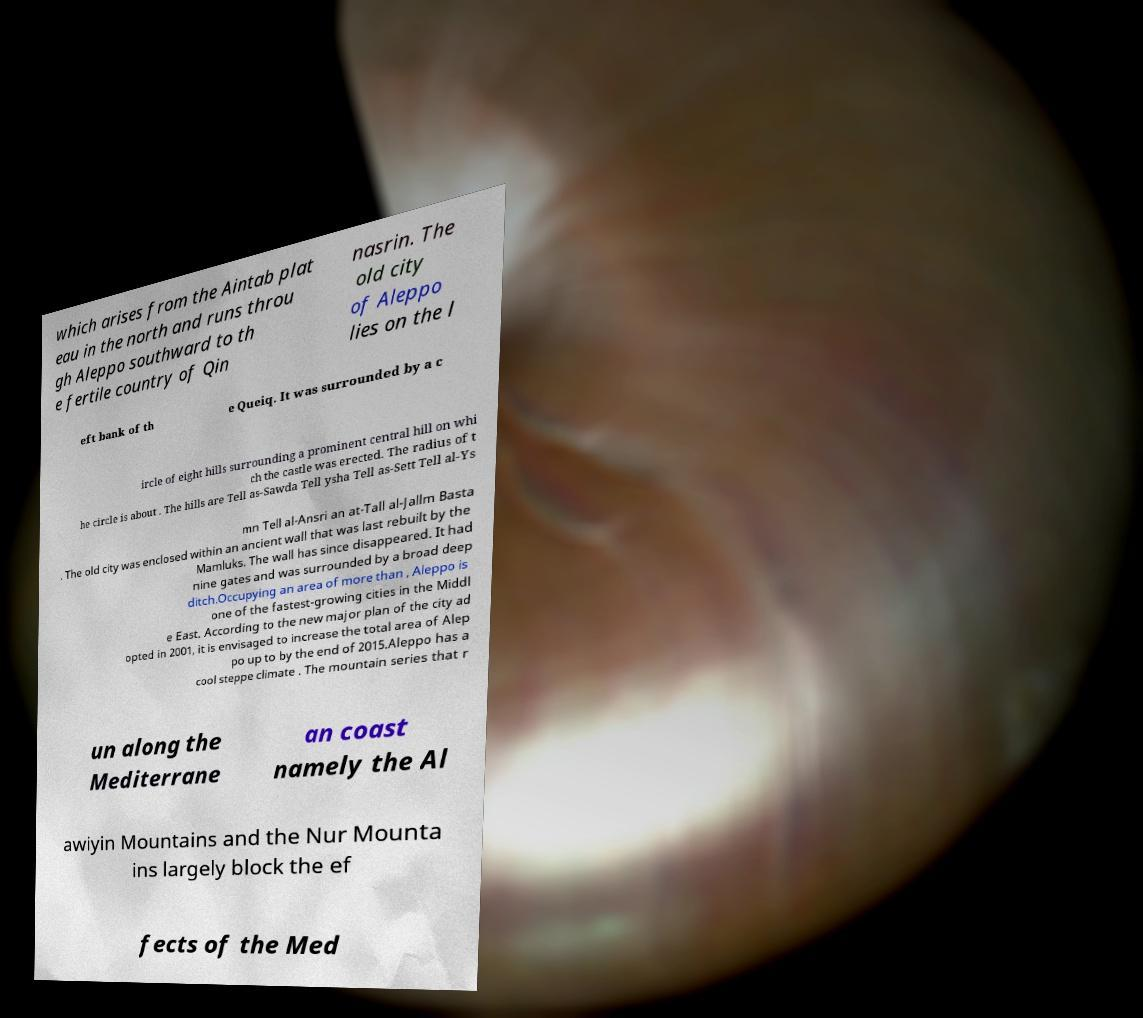Can you read and provide the text displayed in the image?This photo seems to have some interesting text. Can you extract and type it out for me? which arises from the Aintab plat eau in the north and runs throu gh Aleppo southward to th e fertile country of Qin nasrin. The old city of Aleppo lies on the l eft bank of th e Queiq. It was surrounded by a c ircle of eight hills surrounding a prominent central hill on whi ch the castle was erected. The radius of t he circle is about . The hills are Tell as-Sawda Tell ysha Tell as-Sett Tell al-Ys mn Tell al-Ansri an at-Tall al-Jallm Basta . The old city was enclosed within an ancient wall that was last rebuilt by the Mamluks. The wall has since disappeared. It had nine gates and was surrounded by a broad deep ditch.Occupying an area of more than , Aleppo is one of the fastest-growing cities in the Middl e East. According to the new major plan of the city ad opted in 2001, it is envisaged to increase the total area of Alep po up to by the end of 2015.Aleppo has a cool steppe climate . The mountain series that r un along the Mediterrane an coast namely the Al awiyin Mountains and the Nur Mounta ins largely block the ef fects of the Med 